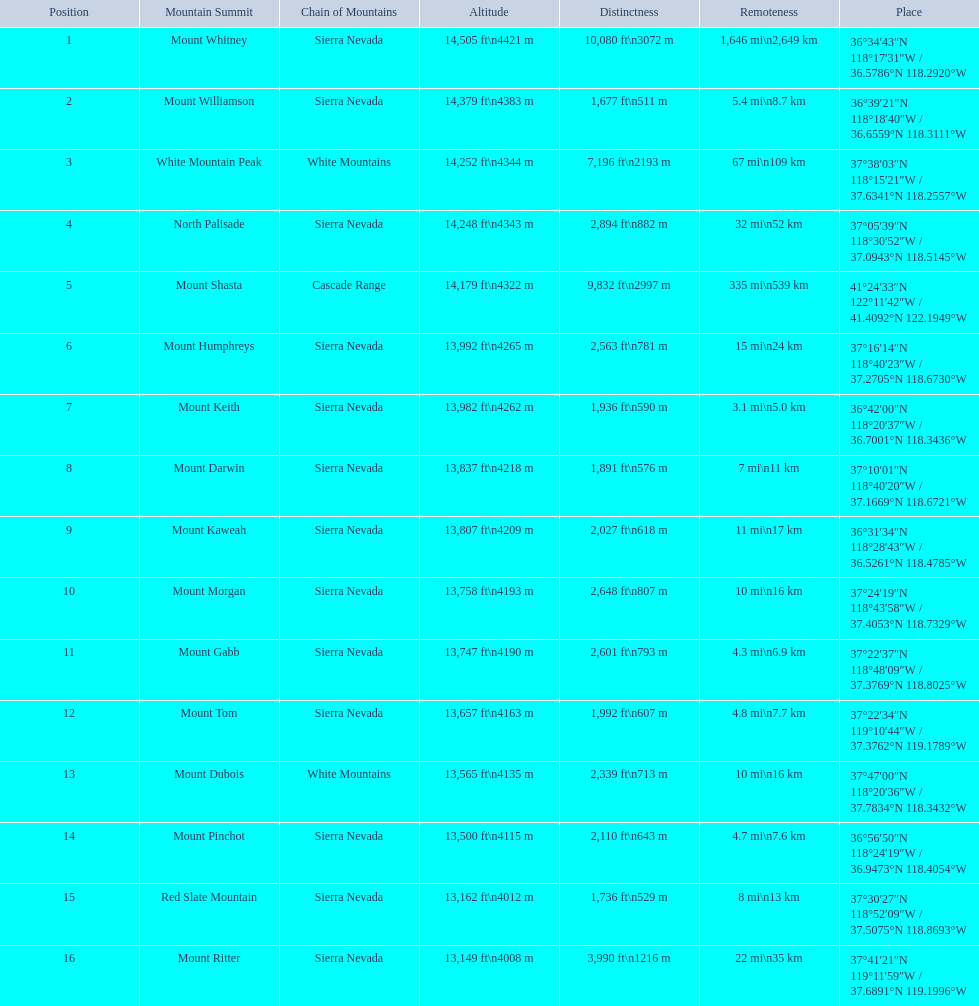What are the prominence lengths higher than 10,000 feet? 10,080 ft\n3072 m. What mountain peak has a prominence of 10,080 feet? Mount Whitney. 